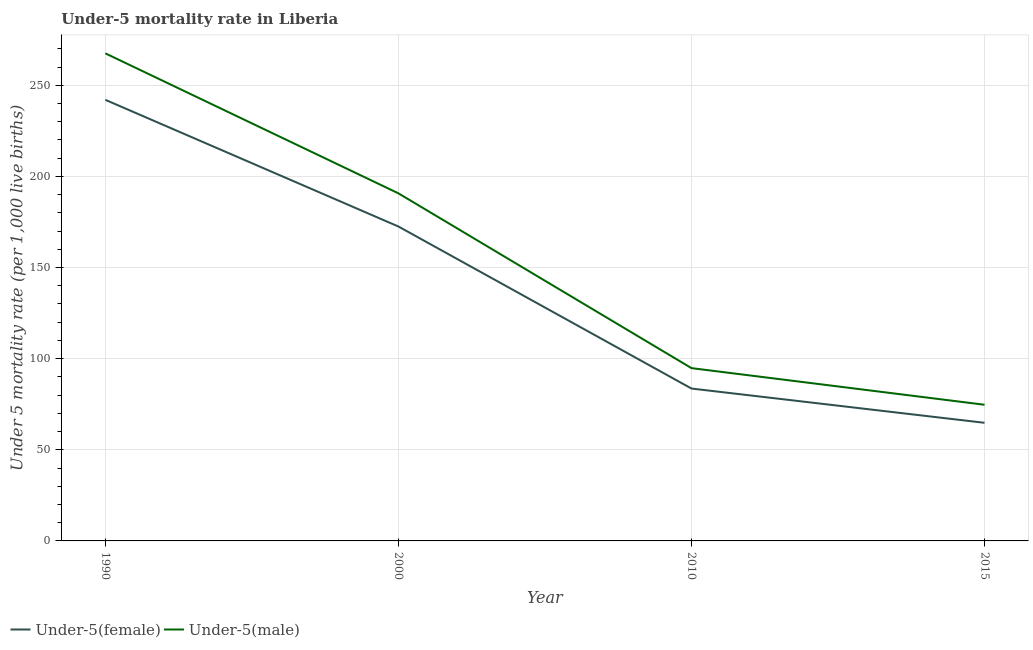Does the line corresponding to under-5 male mortality rate intersect with the line corresponding to under-5 female mortality rate?
Provide a succinct answer. No. Is the number of lines equal to the number of legend labels?
Provide a succinct answer. Yes. What is the under-5 male mortality rate in 1990?
Keep it short and to the point. 267.5. Across all years, what is the maximum under-5 female mortality rate?
Your answer should be compact. 242. Across all years, what is the minimum under-5 female mortality rate?
Offer a very short reply. 64.8. In which year was the under-5 female mortality rate maximum?
Your answer should be compact. 1990. In which year was the under-5 male mortality rate minimum?
Your answer should be very brief. 2015. What is the total under-5 male mortality rate in the graph?
Offer a very short reply. 627.7. What is the difference between the under-5 female mortality rate in 1990 and that in 2010?
Your answer should be compact. 158.4. What is the difference between the under-5 male mortality rate in 2015 and the under-5 female mortality rate in 2010?
Your answer should be compact. -8.9. What is the average under-5 male mortality rate per year?
Offer a very short reply. 156.93. In the year 2015, what is the difference between the under-5 female mortality rate and under-5 male mortality rate?
Keep it short and to the point. -9.9. In how many years, is the under-5 female mortality rate greater than 190?
Provide a short and direct response. 1. What is the ratio of the under-5 male mortality rate in 1990 to that in 2015?
Offer a very short reply. 3.58. Is the under-5 female mortality rate in 2000 less than that in 2015?
Keep it short and to the point. No. What is the difference between the highest and the second highest under-5 female mortality rate?
Ensure brevity in your answer.  69.5. What is the difference between the highest and the lowest under-5 female mortality rate?
Offer a very short reply. 177.2. Is the sum of the under-5 male mortality rate in 2000 and 2015 greater than the maximum under-5 female mortality rate across all years?
Provide a succinct answer. Yes. Does the under-5 female mortality rate monotonically increase over the years?
Your answer should be very brief. No. Is the under-5 male mortality rate strictly greater than the under-5 female mortality rate over the years?
Give a very brief answer. Yes. Are the values on the major ticks of Y-axis written in scientific E-notation?
Your answer should be very brief. No. How are the legend labels stacked?
Offer a terse response. Horizontal. What is the title of the graph?
Your answer should be compact. Under-5 mortality rate in Liberia. Does "Technicians" appear as one of the legend labels in the graph?
Offer a terse response. No. What is the label or title of the X-axis?
Provide a short and direct response. Year. What is the label or title of the Y-axis?
Keep it short and to the point. Under 5 mortality rate (per 1,0 live births). What is the Under 5 mortality rate (per 1,000 live births) of Under-5(female) in 1990?
Your answer should be compact. 242. What is the Under 5 mortality rate (per 1,000 live births) of Under-5(male) in 1990?
Give a very brief answer. 267.5. What is the Under 5 mortality rate (per 1,000 live births) of Under-5(female) in 2000?
Provide a succinct answer. 172.5. What is the Under 5 mortality rate (per 1,000 live births) of Under-5(male) in 2000?
Make the answer very short. 190.7. What is the Under 5 mortality rate (per 1,000 live births) of Under-5(female) in 2010?
Make the answer very short. 83.6. What is the Under 5 mortality rate (per 1,000 live births) in Under-5(male) in 2010?
Give a very brief answer. 94.8. What is the Under 5 mortality rate (per 1,000 live births) of Under-5(female) in 2015?
Your answer should be very brief. 64.8. What is the Under 5 mortality rate (per 1,000 live births) of Under-5(male) in 2015?
Make the answer very short. 74.7. Across all years, what is the maximum Under 5 mortality rate (per 1,000 live births) in Under-5(female)?
Your answer should be very brief. 242. Across all years, what is the maximum Under 5 mortality rate (per 1,000 live births) in Under-5(male)?
Ensure brevity in your answer.  267.5. Across all years, what is the minimum Under 5 mortality rate (per 1,000 live births) of Under-5(female)?
Offer a terse response. 64.8. Across all years, what is the minimum Under 5 mortality rate (per 1,000 live births) of Under-5(male)?
Provide a succinct answer. 74.7. What is the total Under 5 mortality rate (per 1,000 live births) in Under-5(female) in the graph?
Provide a short and direct response. 562.9. What is the total Under 5 mortality rate (per 1,000 live births) in Under-5(male) in the graph?
Your answer should be very brief. 627.7. What is the difference between the Under 5 mortality rate (per 1,000 live births) in Under-5(female) in 1990 and that in 2000?
Provide a short and direct response. 69.5. What is the difference between the Under 5 mortality rate (per 1,000 live births) of Under-5(male) in 1990 and that in 2000?
Make the answer very short. 76.8. What is the difference between the Under 5 mortality rate (per 1,000 live births) of Under-5(female) in 1990 and that in 2010?
Give a very brief answer. 158.4. What is the difference between the Under 5 mortality rate (per 1,000 live births) in Under-5(male) in 1990 and that in 2010?
Make the answer very short. 172.7. What is the difference between the Under 5 mortality rate (per 1,000 live births) in Under-5(female) in 1990 and that in 2015?
Your response must be concise. 177.2. What is the difference between the Under 5 mortality rate (per 1,000 live births) in Under-5(male) in 1990 and that in 2015?
Ensure brevity in your answer.  192.8. What is the difference between the Under 5 mortality rate (per 1,000 live births) of Under-5(female) in 2000 and that in 2010?
Offer a very short reply. 88.9. What is the difference between the Under 5 mortality rate (per 1,000 live births) of Under-5(male) in 2000 and that in 2010?
Provide a succinct answer. 95.9. What is the difference between the Under 5 mortality rate (per 1,000 live births) in Under-5(female) in 2000 and that in 2015?
Make the answer very short. 107.7. What is the difference between the Under 5 mortality rate (per 1,000 live births) in Under-5(male) in 2000 and that in 2015?
Provide a succinct answer. 116. What is the difference between the Under 5 mortality rate (per 1,000 live births) of Under-5(male) in 2010 and that in 2015?
Provide a short and direct response. 20.1. What is the difference between the Under 5 mortality rate (per 1,000 live births) of Under-5(female) in 1990 and the Under 5 mortality rate (per 1,000 live births) of Under-5(male) in 2000?
Keep it short and to the point. 51.3. What is the difference between the Under 5 mortality rate (per 1,000 live births) of Under-5(female) in 1990 and the Under 5 mortality rate (per 1,000 live births) of Under-5(male) in 2010?
Provide a short and direct response. 147.2. What is the difference between the Under 5 mortality rate (per 1,000 live births) in Under-5(female) in 1990 and the Under 5 mortality rate (per 1,000 live births) in Under-5(male) in 2015?
Provide a short and direct response. 167.3. What is the difference between the Under 5 mortality rate (per 1,000 live births) in Under-5(female) in 2000 and the Under 5 mortality rate (per 1,000 live births) in Under-5(male) in 2010?
Offer a terse response. 77.7. What is the difference between the Under 5 mortality rate (per 1,000 live births) in Under-5(female) in 2000 and the Under 5 mortality rate (per 1,000 live births) in Under-5(male) in 2015?
Ensure brevity in your answer.  97.8. What is the difference between the Under 5 mortality rate (per 1,000 live births) in Under-5(female) in 2010 and the Under 5 mortality rate (per 1,000 live births) in Under-5(male) in 2015?
Provide a succinct answer. 8.9. What is the average Under 5 mortality rate (per 1,000 live births) in Under-5(female) per year?
Ensure brevity in your answer.  140.72. What is the average Under 5 mortality rate (per 1,000 live births) in Under-5(male) per year?
Ensure brevity in your answer.  156.93. In the year 1990, what is the difference between the Under 5 mortality rate (per 1,000 live births) in Under-5(female) and Under 5 mortality rate (per 1,000 live births) in Under-5(male)?
Make the answer very short. -25.5. In the year 2000, what is the difference between the Under 5 mortality rate (per 1,000 live births) of Under-5(female) and Under 5 mortality rate (per 1,000 live births) of Under-5(male)?
Give a very brief answer. -18.2. In the year 2015, what is the difference between the Under 5 mortality rate (per 1,000 live births) of Under-5(female) and Under 5 mortality rate (per 1,000 live births) of Under-5(male)?
Provide a succinct answer. -9.9. What is the ratio of the Under 5 mortality rate (per 1,000 live births) in Under-5(female) in 1990 to that in 2000?
Provide a succinct answer. 1.4. What is the ratio of the Under 5 mortality rate (per 1,000 live births) in Under-5(male) in 1990 to that in 2000?
Give a very brief answer. 1.4. What is the ratio of the Under 5 mortality rate (per 1,000 live births) of Under-5(female) in 1990 to that in 2010?
Your response must be concise. 2.89. What is the ratio of the Under 5 mortality rate (per 1,000 live births) of Under-5(male) in 1990 to that in 2010?
Provide a short and direct response. 2.82. What is the ratio of the Under 5 mortality rate (per 1,000 live births) of Under-5(female) in 1990 to that in 2015?
Your answer should be compact. 3.73. What is the ratio of the Under 5 mortality rate (per 1,000 live births) of Under-5(male) in 1990 to that in 2015?
Your response must be concise. 3.58. What is the ratio of the Under 5 mortality rate (per 1,000 live births) in Under-5(female) in 2000 to that in 2010?
Offer a very short reply. 2.06. What is the ratio of the Under 5 mortality rate (per 1,000 live births) in Under-5(male) in 2000 to that in 2010?
Keep it short and to the point. 2.01. What is the ratio of the Under 5 mortality rate (per 1,000 live births) in Under-5(female) in 2000 to that in 2015?
Your response must be concise. 2.66. What is the ratio of the Under 5 mortality rate (per 1,000 live births) in Under-5(male) in 2000 to that in 2015?
Make the answer very short. 2.55. What is the ratio of the Under 5 mortality rate (per 1,000 live births) of Under-5(female) in 2010 to that in 2015?
Offer a terse response. 1.29. What is the ratio of the Under 5 mortality rate (per 1,000 live births) of Under-5(male) in 2010 to that in 2015?
Your response must be concise. 1.27. What is the difference between the highest and the second highest Under 5 mortality rate (per 1,000 live births) of Under-5(female)?
Your response must be concise. 69.5. What is the difference between the highest and the second highest Under 5 mortality rate (per 1,000 live births) in Under-5(male)?
Ensure brevity in your answer.  76.8. What is the difference between the highest and the lowest Under 5 mortality rate (per 1,000 live births) of Under-5(female)?
Ensure brevity in your answer.  177.2. What is the difference between the highest and the lowest Under 5 mortality rate (per 1,000 live births) in Under-5(male)?
Provide a short and direct response. 192.8. 